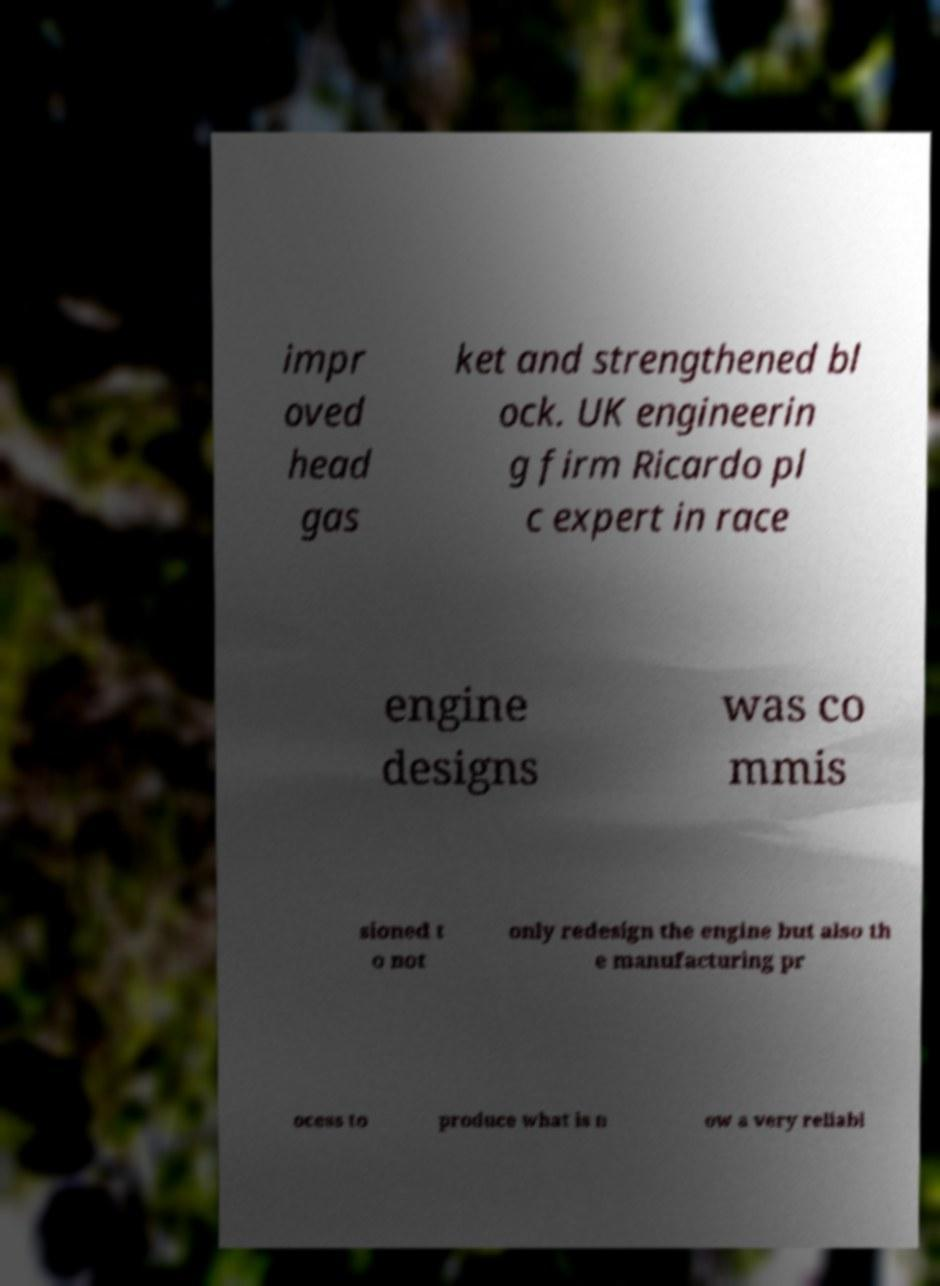There's text embedded in this image that I need extracted. Can you transcribe it verbatim? impr oved head gas ket and strengthened bl ock. UK engineerin g firm Ricardo pl c expert in race engine designs was co mmis sioned t o not only redesign the engine but also th e manufacturing pr ocess to produce what is n ow a very reliabl 